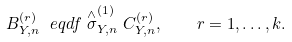<formula> <loc_0><loc_0><loc_500><loc_500>B _ { Y , n } ^ { ( r ) } \ e q d f \stackrel { \wedge } { \sigma } ^ { ( 1 ) } _ { Y , n } C _ { Y , n } ^ { ( r ) } , \quad r = 1 , \dots , k .</formula> 